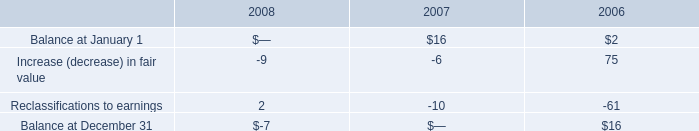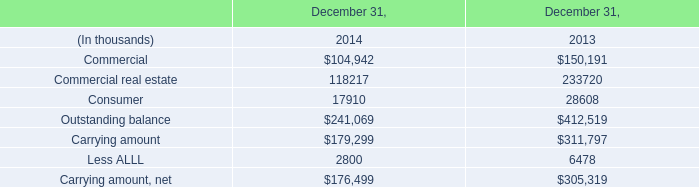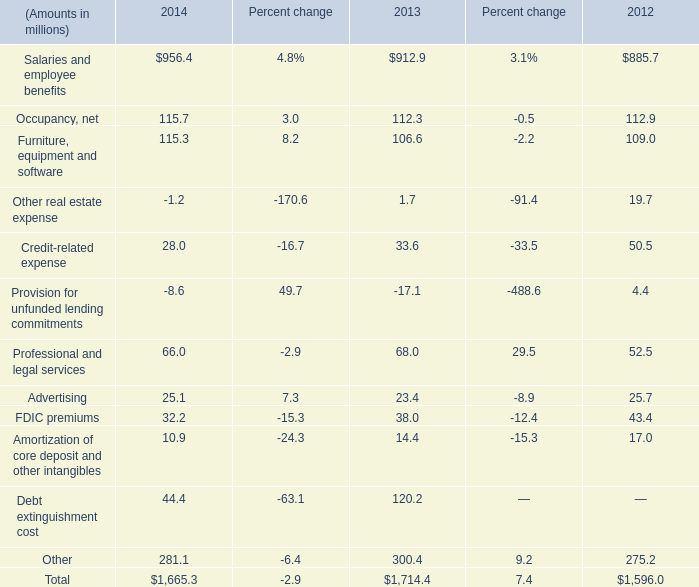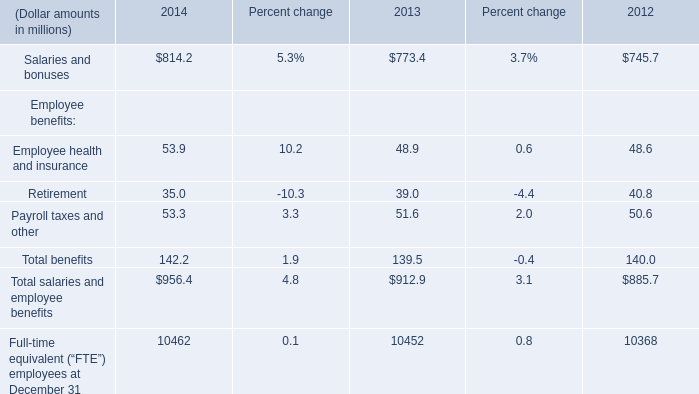what was the percent change in balance of stockholder equity from the beginning to the end of 2006? 
Computations: ((16 - 2) / 2)
Answer: 7.0. 